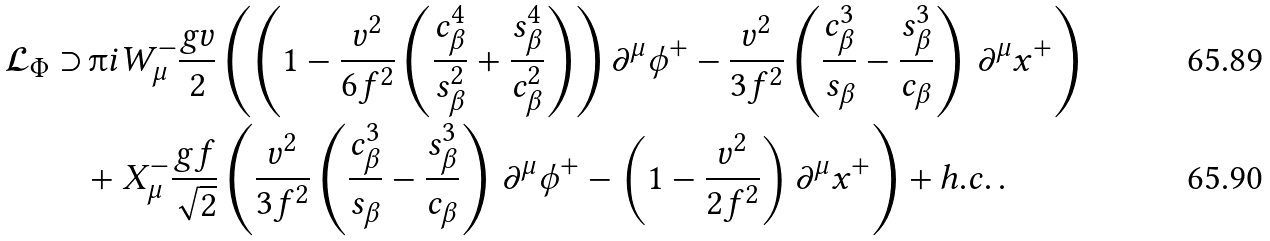<formula> <loc_0><loc_0><loc_500><loc_500>\mathcal { L } _ { \Phi } \supset & \, \i i W ^ { - } _ { \mu } \frac { g v } { 2 } \left ( \left ( 1 - \frac { v ^ { 2 } } { 6 f ^ { 2 } } \left ( \frac { c _ { \beta } ^ { 4 } } { s _ { \beta } ^ { 2 } } + \frac { s _ { \beta } ^ { 4 } } { c _ { \beta } ^ { 2 } } \right ) \right ) \partial ^ { \mu } \phi ^ { + } - \frac { v ^ { 2 } } { 3 f ^ { 2 } } \left ( \frac { c _ { \beta } ^ { 3 } } { s _ { \beta } } - \frac { s _ { \beta } ^ { 3 } } { c _ { \beta } } \right ) \, \partial ^ { \mu } x ^ { + } \right ) \\ & + X ^ { - } _ { \mu } \frac { g f } { \sqrt { 2 } } \left ( \frac { v ^ { 2 } } { 3 f ^ { 2 } } \left ( \frac { c _ { \beta } ^ { 3 } } { s _ { \beta } } - \frac { s _ { \beta } ^ { 3 } } { c _ { \beta } } \right ) \, \partial ^ { \mu } \phi ^ { + } - \left ( 1 - \frac { v ^ { 2 } } { 2 f ^ { 2 } } \right ) \partial ^ { \mu } x ^ { + } \right ) + h . c . \, .</formula> 